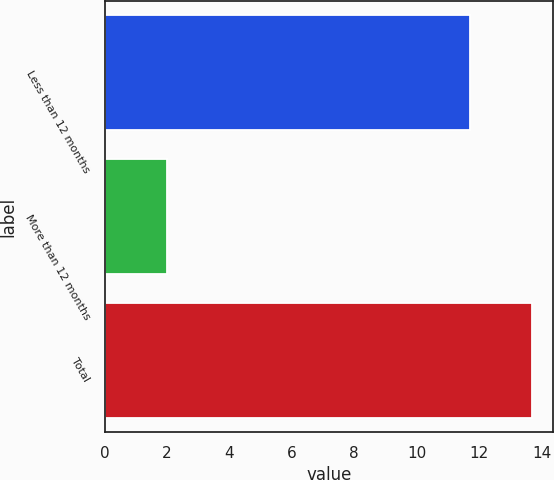Convert chart. <chart><loc_0><loc_0><loc_500><loc_500><bar_chart><fcel>Less than 12 months<fcel>More than 12 months<fcel>Total<nl><fcel>11.7<fcel>2<fcel>13.7<nl></chart> 